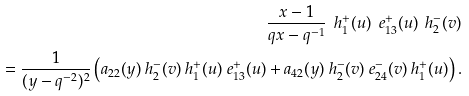<formula> <loc_0><loc_0><loc_500><loc_500>\frac { x - 1 } { q x - q ^ { - 1 } } \ h _ { 1 } ^ { + } ( u ) \ e _ { 1 3 } ^ { + } ( u ) \ h _ { 2 } ^ { - } ( v ) \\ = \frac { 1 } { ( y - q ^ { - 2 } ) ^ { 2 } } \left ( a _ { 2 2 } ( y ) \ h _ { 2 } ^ { - } ( v ) \ h _ { 1 } ^ { + } ( u ) \ e _ { 1 3 } ^ { + } ( u ) + a _ { 4 2 } ( y ) \ h _ { 2 } ^ { - } ( v ) \ e _ { 2 4 } ^ { - } ( v ) \ h _ { 1 } ^ { + } ( u ) \right ) .</formula> 